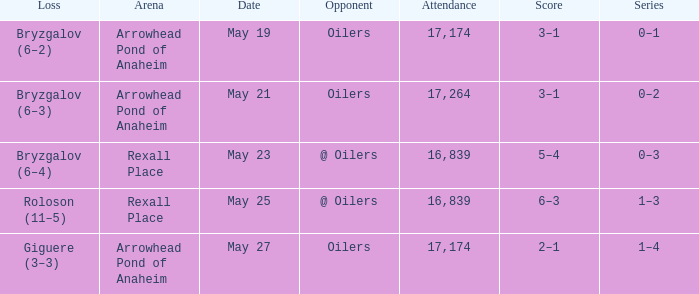Which Attendance has an Opponent of @ oilers, and a Date of may 25? 16839.0. 